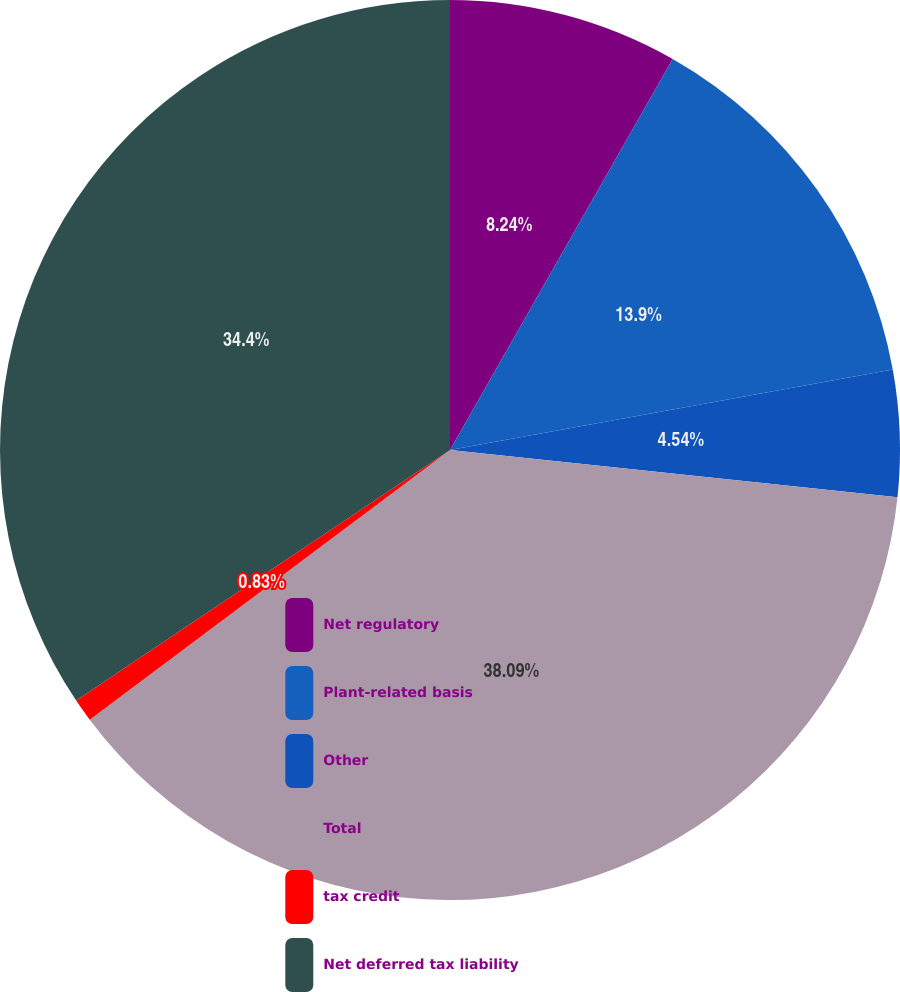Convert chart to OTSL. <chart><loc_0><loc_0><loc_500><loc_500><pie_chart><fcel>Net regulatory<fcel>Plant-related basis<fcel>Other<fcel>Total<fcel>tax credit<fcel>Net deferred tax liability<nl><fcel>8.24%<fcel>13.9%<fcel>4.54%<fcel>38.1%<fcel>0.83%<fcel>34.4%<nl></chart> 